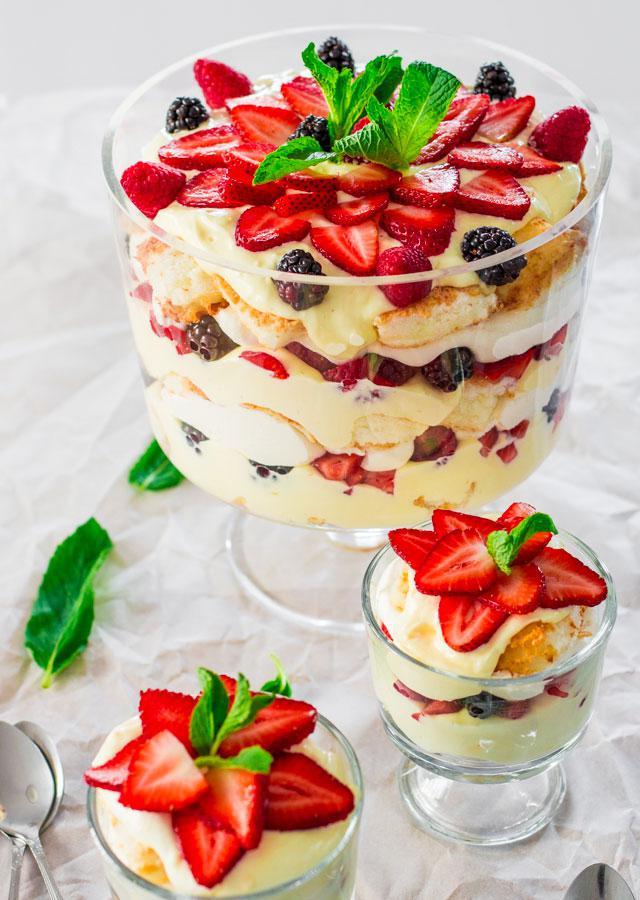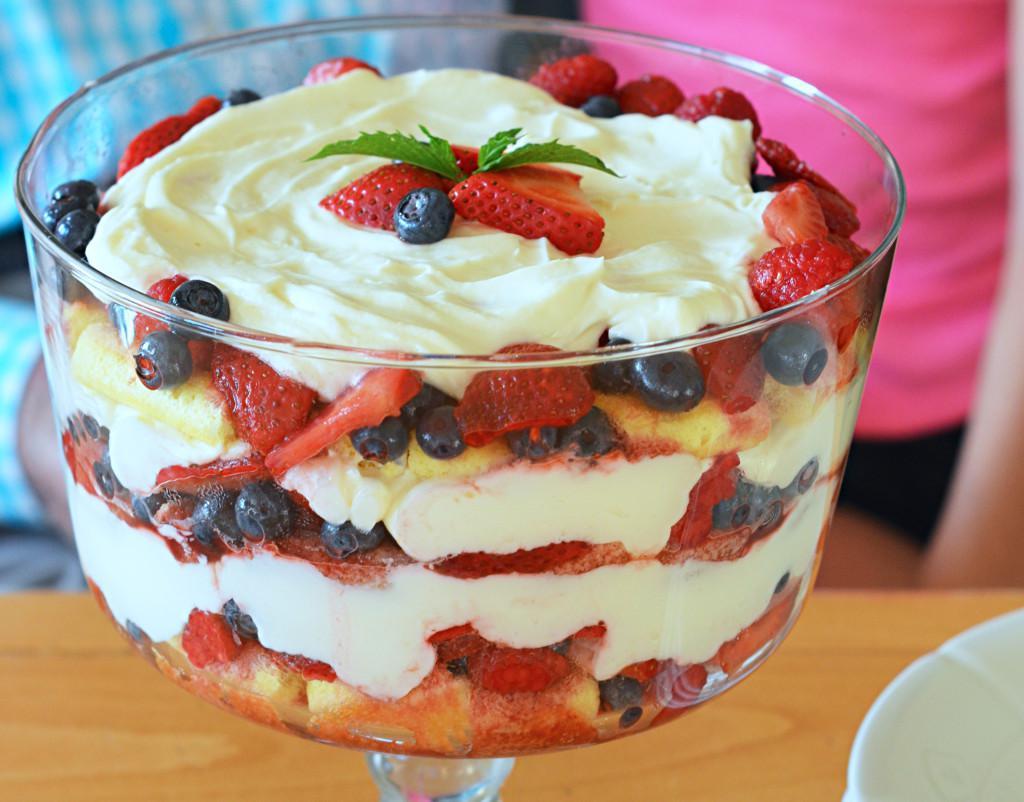The first image is the image on the left, the second image is the image on the right. For the images shown, is this caption "A trifle is garnished with pomegranite seeds arranged in a spoke pattern." true? Answer yes or no. No. 